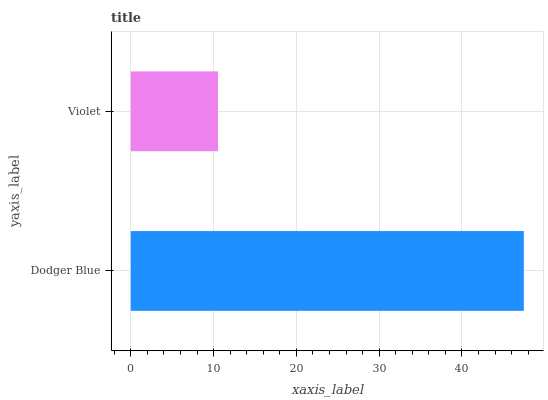Is Violet the minimum?
Answer yes or no. Yes. Is Dodger Blue the maximum?
Answer yes or no. Yes. Is Violet the maximum?
Answer yes or no. No. Is Dodger Blue greater than Violet?
Answer yes or no. Yes. Is Violet less than Dodger Blue?
Answer yes or no. Yes. Is Violet greater than Dodger Blue?
Answer yes or no. No. Is Dodger Blue less than Violet?
Answer yes or no. No. Is Dodger Blue the high median?
Answer yes or no. Yes. Is Violet the low median?
Answer yes or no. Yes. Is Violet the high median?
Answer yes or no. No. Is Dodger Blue the low median?
Answer yes or no. No. 